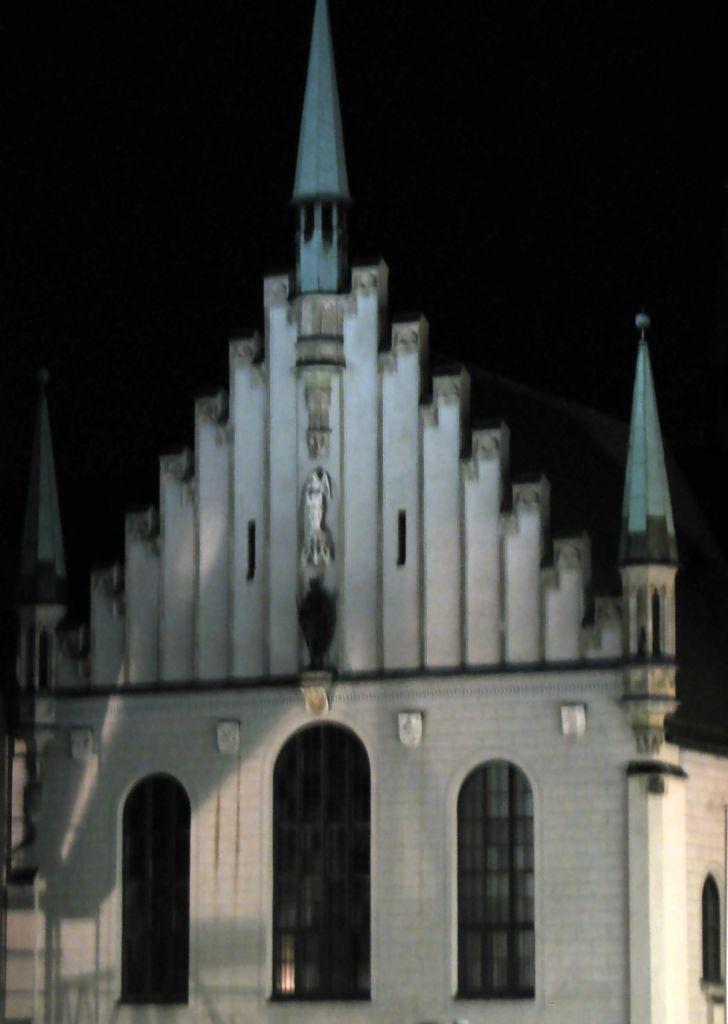How would you summarize this image in a sentence or two? In the center of the image there is a building. In the background we can see sky. 